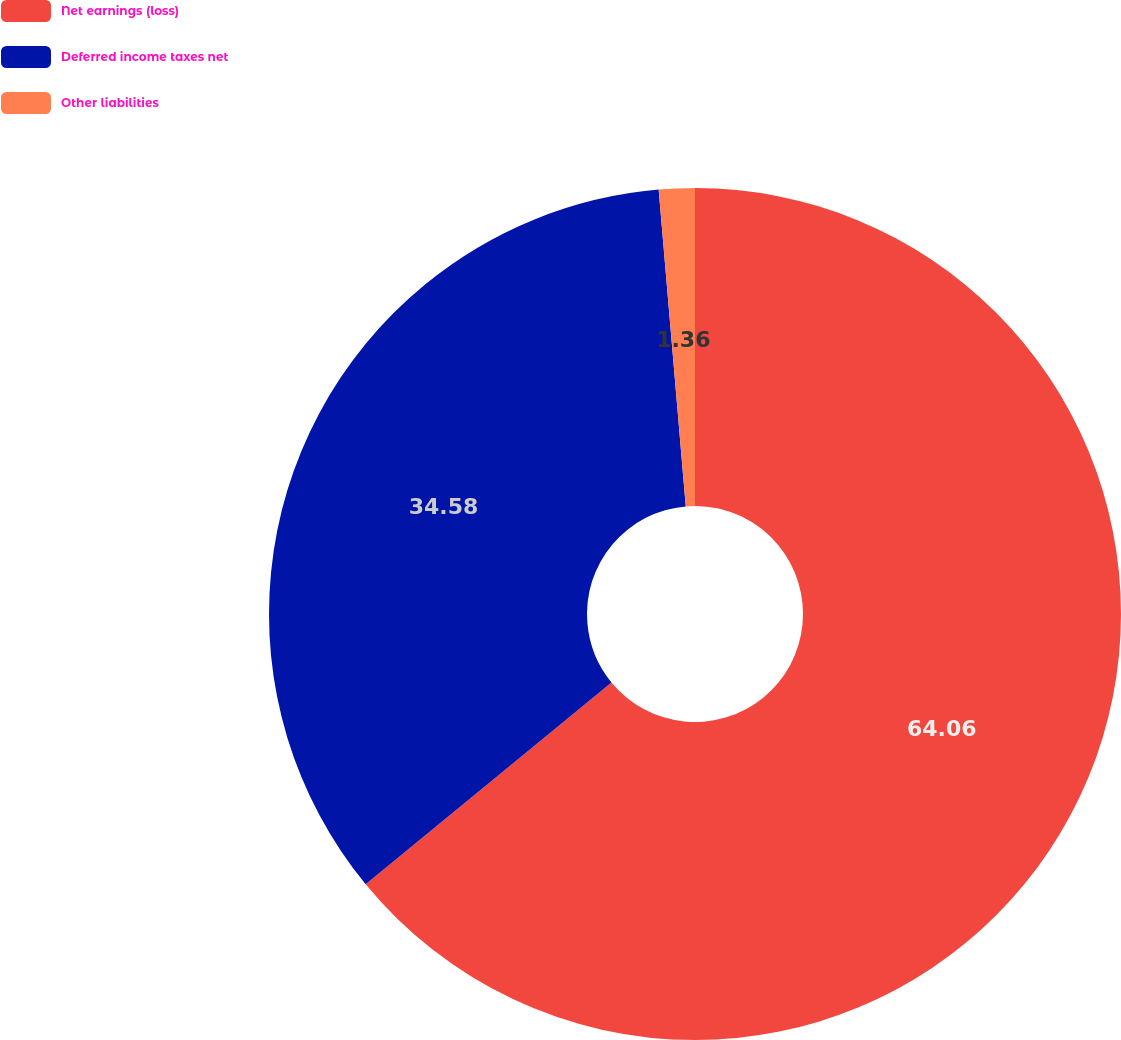Convert chart to OTSL. <chart><loc_0><loc_0><loc_500><loc_500><pie_chart><fcel>Net earnings (loss)<fcel>Deferred income taxes net<fcel>Other liabilities<nl><fcel>64.07%<fcel>34.58%<fcel>1.36%<nl></chart> 